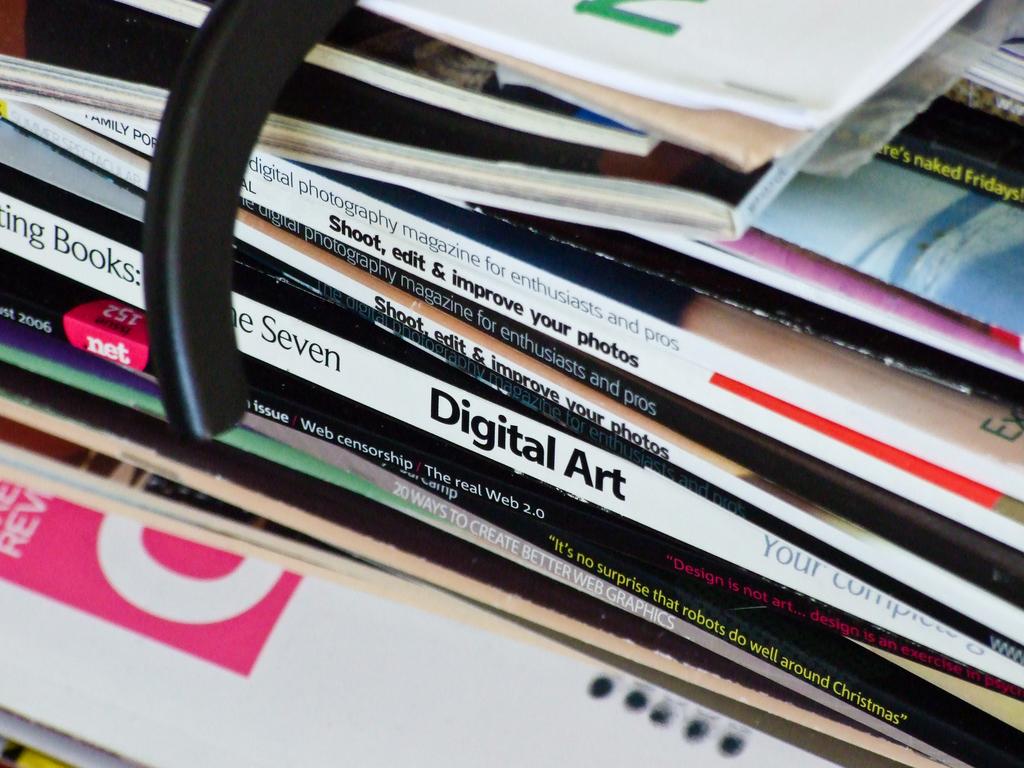What common theme do most of these books share?
Your answer should be very brief. Art. Is there a book about photo editing in this pile?
Provide a short and direct response. Yes. 